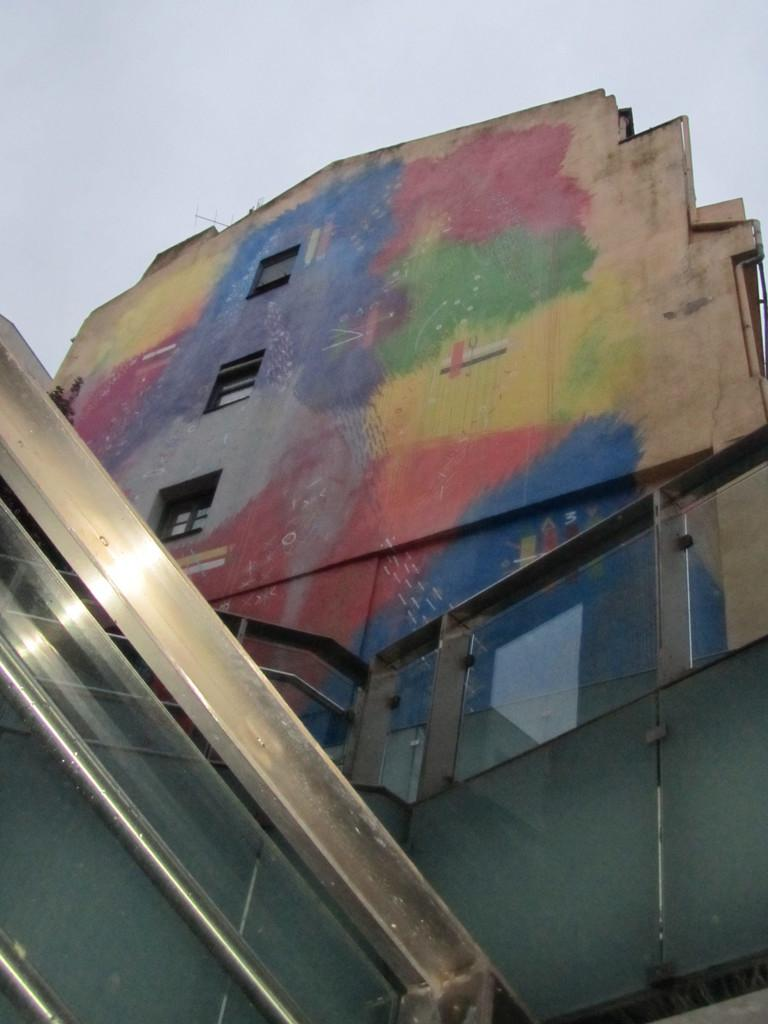What type of structure is visible in the image? There is a building in the image. What feature can be seen on the building? The building has windows. What is in front of the building? There is a glass railing in front of the building. How has the wall of the building been decorated? The wall of the building is painted with different colors. What is the color of the sky in the image? The sky appears to be white in color. What type of oil can be seen dripping from the building in the image? There is no oil present in the image, and therefore no such dripping can be observed. Are there any pests visible on the building in the image? There is no mention of pests in the image, and therefore no such creatures can be observed. 